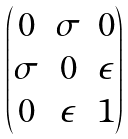Convert formula to latex. <formula><loc_0><loc_0><loc_500><loc_500>\begin{pmatrix} 0 & \sigma & 0 \\ \sigma & 0 & \epsilon \\ 0 & \epsilon & 1 \end{pmatrix}</formula> 